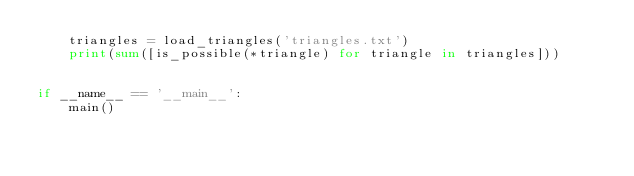<code> <loc_0><loc_0><loc_500><loc_500><_Python_>    triangles = load_triangles('triangles.txt')
    print(sum([is_possible(*triangle) for triangle in triangles]))


if __name__ == '__main__':
    main()
</code> 